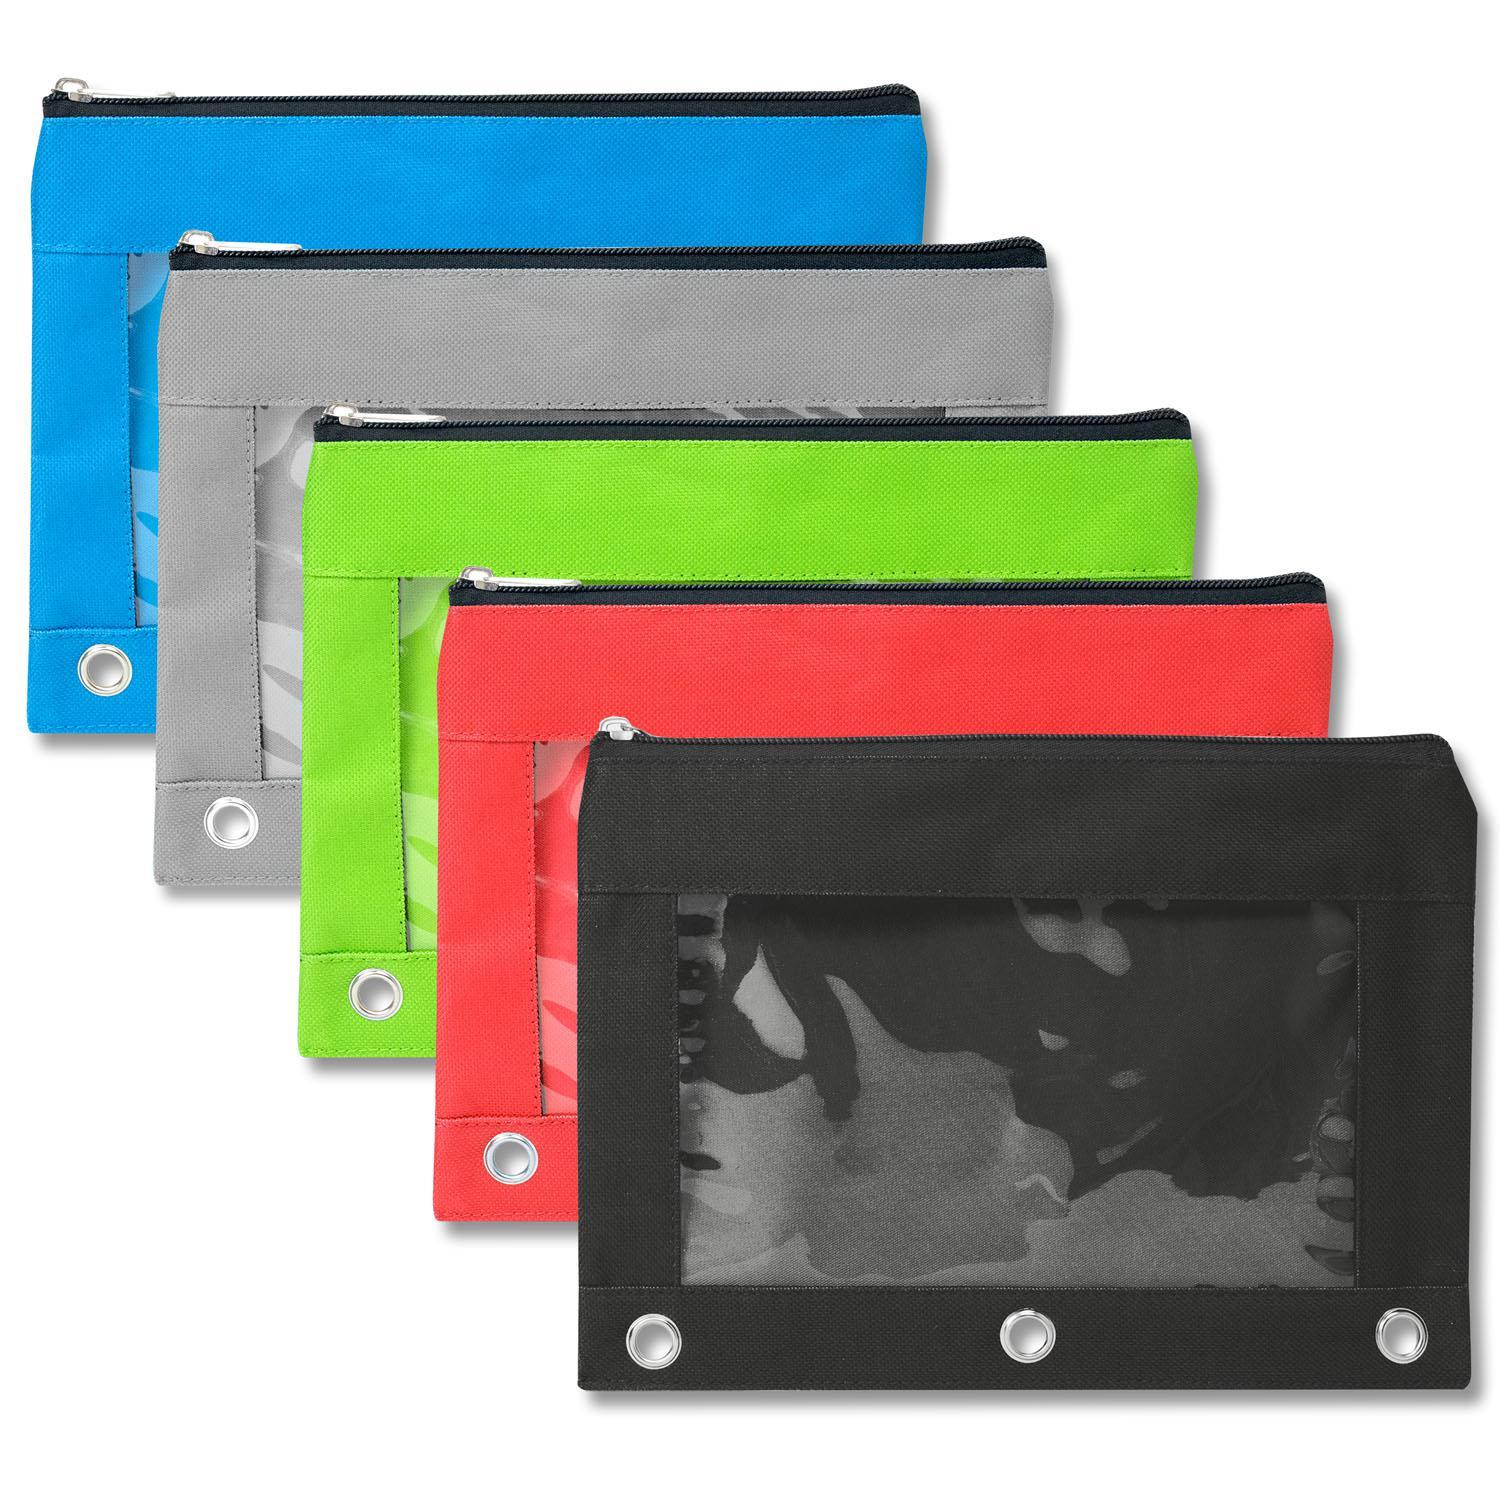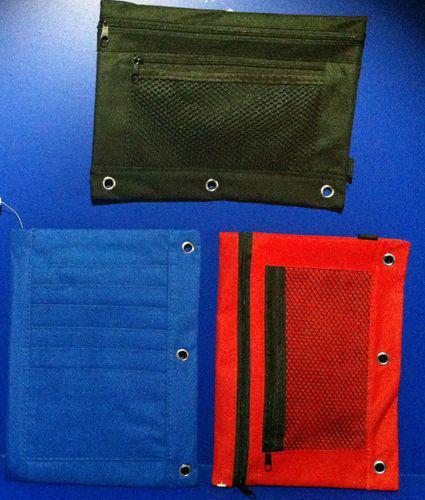The first image is the image on the left, the second image is the image on the right. Examine the images to the left and right. Is the description "There are three pencil cases in the right image." accurate? Answer yes or no. Yes. The first image is the image on the left, the second image is the image on the right. Assess this claim about the two images: "An image shows at least five different solid-colored pencil cases with eyelets on one edge.". Correct or not? Answer yes or no. Yes. 